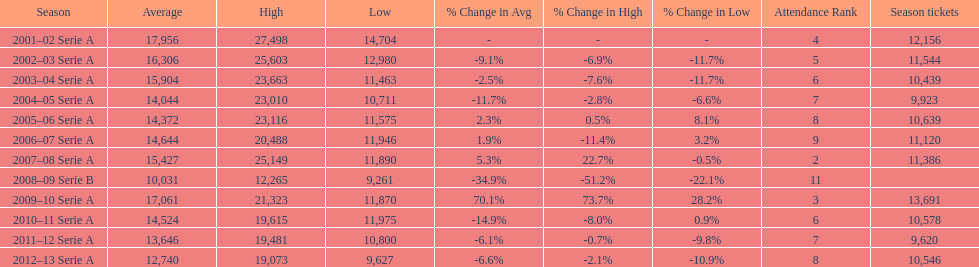What was the average in 2001 17,956. 